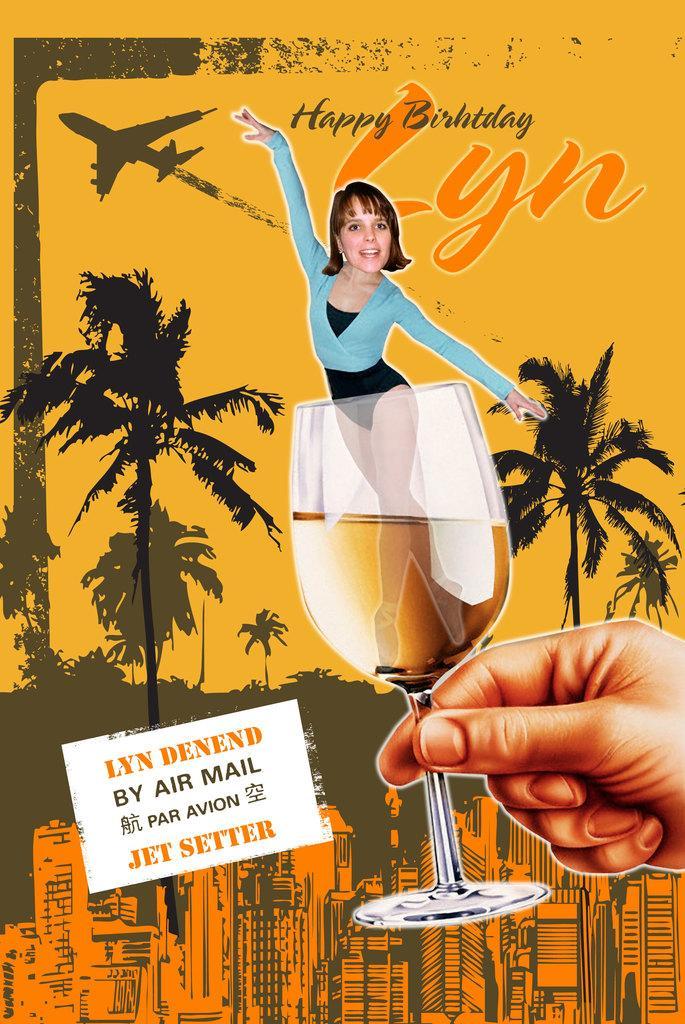In one or two sentences, can you explain what this image depicts? In this image I can see there is a poster and there is a person's hand holding a glass and in that glass there is a woman. And there is some text written on the poster. And there are buildings, Trees, Airplane and a board with text. 